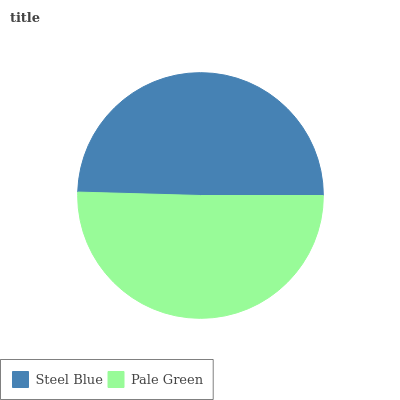Is Steel Blue the minimum?
Answer yes or no. Yes. Is Pale Green the maximum?
Answer yes or no. Yes. Is Pale Green the minimum?
Answer yes or no. No. Is Pale Green greater than Steel Blue?
Answer yes or no. Yes. Is Steel Blue less than Pale Green?
Answer yes or no. Yes. Is Steel Blue greater than Pale Green?
Answer yes or no. No. Is Pale Green less than Steel Blue?
Answer yes or no. No. Is Pale Green the high median?
Answer yes or no. Yes. Is Steel Blue the low median?
Answer yes or no. Yes. Is Steel Blue the high median?
Answer yes or no. No. Is Pale Green the low median?
Answer yes or no. No. 